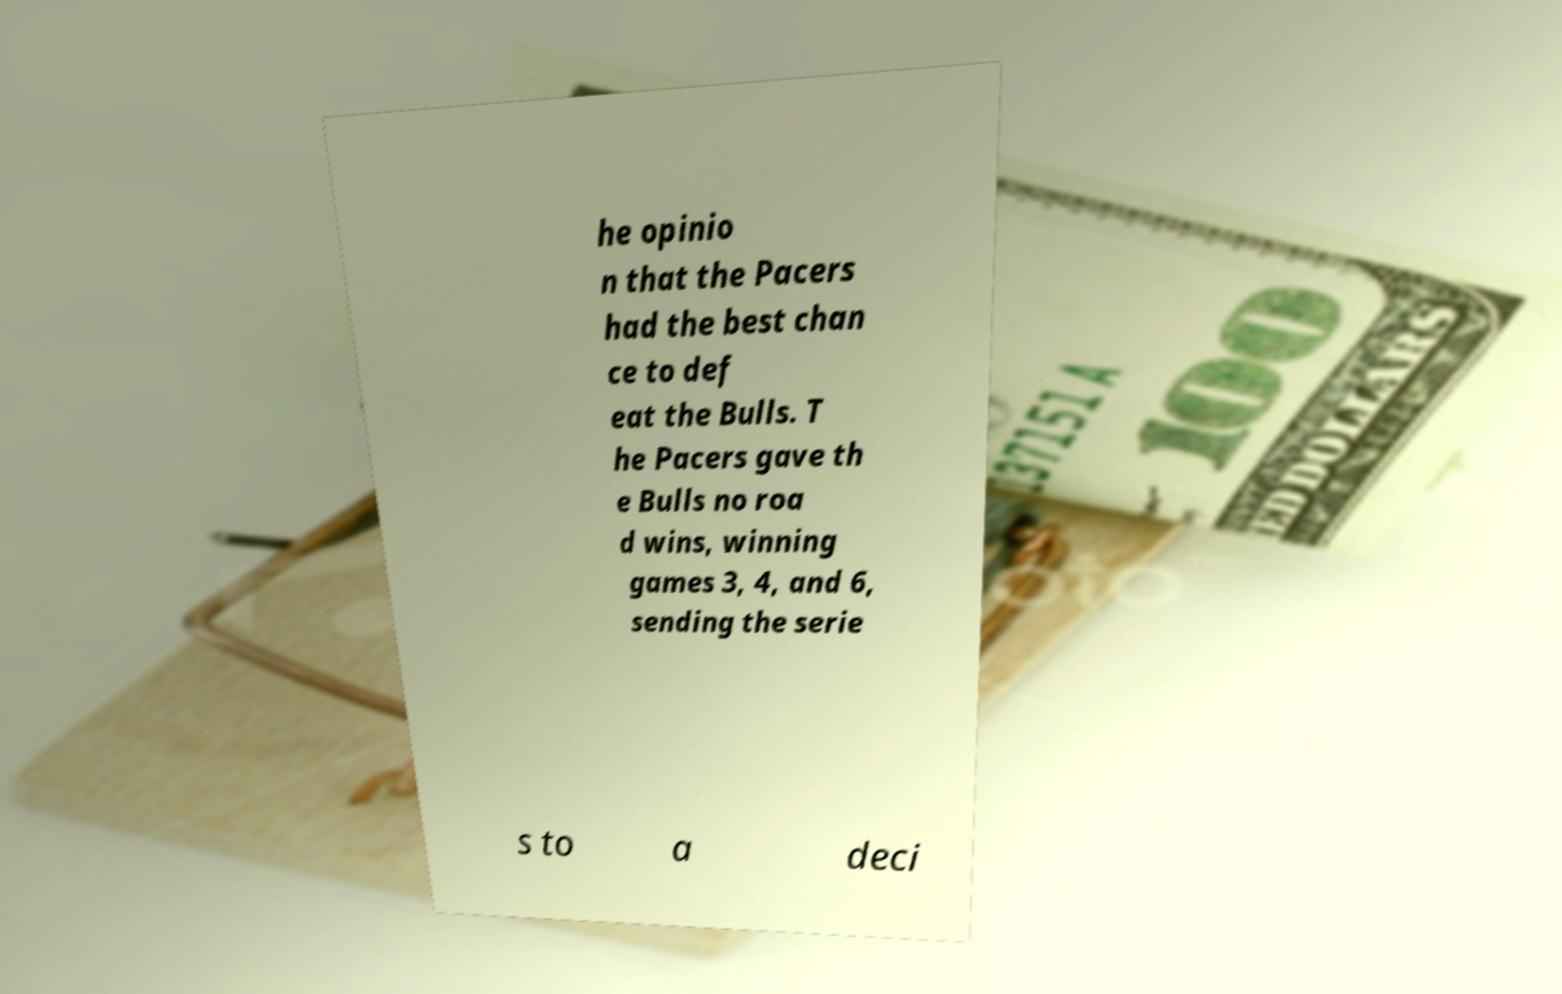Please identify and transcribe the text found in this image. he opinio n that the Pacers had the best chan ce to def eat the Bulls. T he Pacers gave th e Bulls no roa d wins, winning games 3, 4, and 6, sending the serie s to a deci 